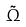Convert formula to latex. <formula><loc_0><loc_0><loc_500><loc_500>\tilde { \Omega }</formula> 